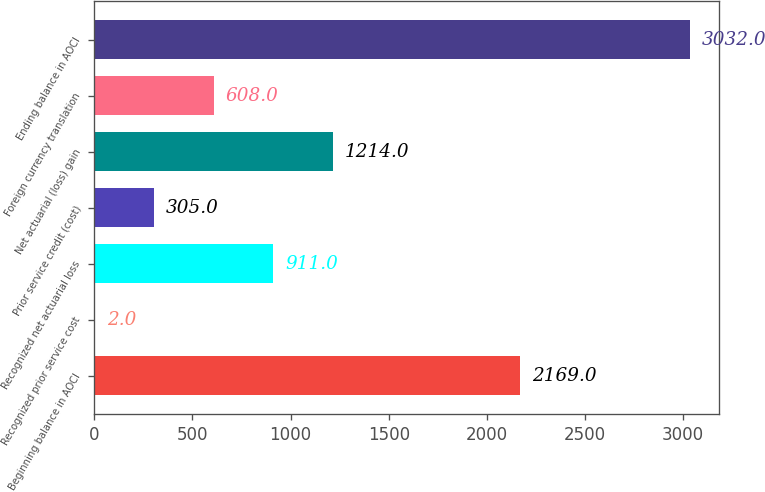Convert chart to OTSL. <chart><loc_0><loc_0><loc_500><loc_500><bar_chart><fcel>Beginning balance in AOCI<fcel>Recognized prior service cost<fcel>Recognized net actuarial loss<fcel>Prior service credit (cost)<fcel>Net actuarial (loss) gain<fcel>Foreign currency translation<fcel>Ending balance in AOCI<nl><fcel>2169<fcel>2<fcel>911<fcel>305<fcel>1214<fcel>608<fcel>3032<nl></chart> 